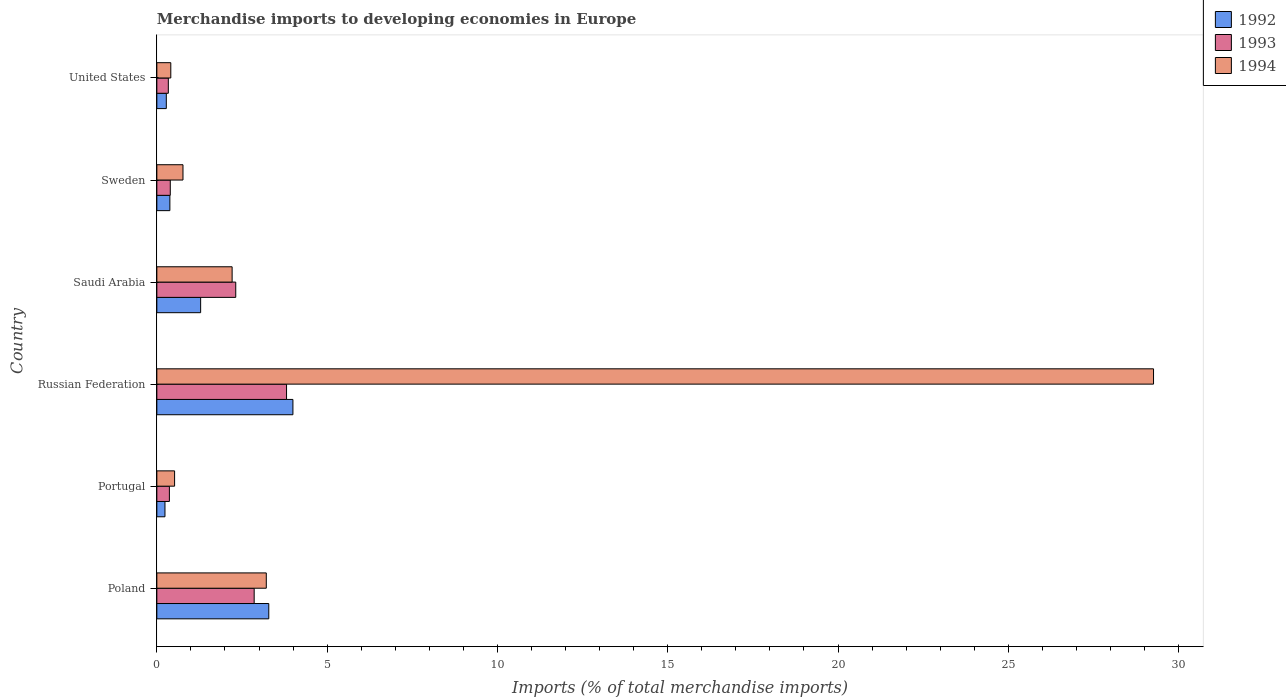Are the number of bars per tick equal to the number of legend labels?
Give a very brief answer. Yes. Are the number of bars on each tick of the Y-axis equal?
Offer a very short reply. Yes. What is the label of the 2nd group of bars from the top?
Offer a terse response. Sweden. In how many cases, is the number of bars for a given country not equal to the number of legend labels?
Provide a short and direct response. 0. What is the percentage total merchandise imports in 1992 in Saudi Arabia?
Offer a terse response. 1.29. Across all countries, what is the maximum percentage total merchandise imports in 1993?
Provide a short and direct response. 3.81. Across all countries, what is the minimum percentage total merchandise imports in 1993?
Make the answer very short. 0.34. In which country was the percentage total merchandise imports in 1994 maximum?
Offer a terse response. Russian Federation. What is the total percentage total merchandise imports in 1992 in the graph?
Keep it short and to the point. 9.47. What is the difference between the percentage total merchandise imports in 1993 in Russian Federation and that in Sweden?
Provide a succinct answer. 3.41. What is the difference between the percentage total merchandise imports in 1993 in Russian Federation and the percentage total merchandise imports in 1994 in Poland?
Your answer should be very brief. 0.59. What is the average percentage total merchandise imports in 1992 per country?
Your answer should be very brief. 1.58. What is the difference between the percentage total merchandise imports in 1994 and percentage total merchandise imports in 1993 in Saudi Arabia?
Provide a succinct answer. -0.11. What is the ratio of the percentage total merchandise imports in 1992 in Saudi Arabia to that in United States?
Ensure brevity in your answer.  4.63. What is the difference between the highest and the second highest percentage total merchandise imports in 1994?
Give a very brief answer. 26.05. What is the difference between the highest and the lowest percentage total merchandise imports in 1994?
Ensure brevity in your answer.  28.85. In how many countries, is the percentage total merchandise imports in 1994 greater than the average percentage total merchandise imports in 1994 taken over all countries?
Give a very brief answer. 1. Is the sum of the percentage total merchandise imports in 1992 in Poland and Sweden greater than the maximum percentage total merchandise imports in 1993 across all countries?
Make the answer very short. No. How many bars are there?
Offer a terse response. 18. Are all the bars in the graph horizontal?
Offer a very short reply. Yes. How many countries are there in the graph?
Your answer should be compact. 6. Are the values on the major ticks of X-axis written in scientific E-notation?
Offer a terse response. No. Does the graph contain any zero values?
Make the answer very short. No. How many legend labels are there?
Your response must be concise. 3. How are the legend labels stacked?
Your answer should be compact. Vertical. What is the title of the graph?
Your response must be concise. Merchandise imports to developing economies in Europe. What is the label or title of the X-axis?
Keep it short and to the point. Imports (% of total merchandise imports). What is the label or title of the Y-axis?
Provide a succinct answer. Country. What is the Imports (% of total merchandise imports) in 1992 in Poland?
Ensure brevity in your answer.  3.29. What is the Imports (% of total merchandise imports) in 1993 in Poland?
Provide a short and direct response. 2.86. What is the Imports (% of total merchandise imports) of 1994 in Poland?
Offer a terse response. 3.21. What is the Imports (% of total merchandise imports) of 1992 in Portugal?
Provide a short and direct response. 0.24. What is the Imports (% of total merchandise imports) in 1993 in Portugal?
Keep it short and to the point. 0.37. What is the Imports (% of total merchandise imports) of 1994 in Portugal?
Make the answer very short. 0.52. What is the Imports (% of total merchandise imports) in 1992 in Russian Federation?
Offer a very short reply. 4. What is the Imports (% of total merchandise imports) of 1993 in Russian Federation?
Your answer should be very brief. 3.81. What is the Imports (% of total merchandise imports) of 1994 in Russian Federation?
Offer a terse response. 29.26. What is the Imports (% of total merchandise imports) of 1992 in Saudi Arabia?
Ensure brevity in your answer.  1.29. What is the Imports (% of total merchandise imports) of 1993 in Saudi Arabia?
Provide a short and direct response. 2.32. What is the Imports (% of total merchandise imports) in 1994 in Saudi Arabia?
Keep it short and to the point. 2.21. What is the Imports (% of total merchandise imports) in 1992 in Sweden?
Make the answer very short. 0.38. What is the Imports (% of total merchandise imports) in 1993 in Sweden?
Provide a succinct answer. 0.39. What is the Imports (% of total merchandise imports) in 1994 in Sweden?
Make the answer very short. 0.77. What is the Imports (% of total merchandise imports) in 1992 in United States?
Make the answer very short. 0.28. What is the Imports (% of total merchandise imports) in 1993 in United States?
Offer a terse response. 0.34. What is the Imports (% of total merchandise imports) in 1994 in United States?
Provide a succinct answer. 0.41. Across all countries, what is the maximum Imports (% of total merchandise imports) in 1992?
Your answer should be very brief. 4. Across all countries, what is the maximum Imports (% of total merchandise imports) in 1993?
Your answer should be compact. 3.81. Across all countries, what is the maximum Imports (% of total merchandise imports) of 1994?
Give a very brief answer. 29.26. Across all countries, what is the minimum Imports (% of total merchandise imports) of 1992?
Provide a short and direct response. 0.24. Across all countries, what is the minimum Imports (% of total merchandise imports) of 1993?
Your answer should be very brief. 0.34. Across all countries, what is the minimum Imports (% of total merchandise imports) of 1994?
Provide a short and direct response. 0.41. What is the total Imports (% of total merchandise imports) of 1992 in the graph?
Provide a short and direct response. 9.47. What is the total Imports (% of total merchandise imports) of 1993 in the graph?
Your answer should be very brief. 10.08. What is the total Imports (% of total merchandise imports) of 1994 in the graph?
Offer a very short reply. 36.39. What is the difference between the Imports (% of total merchandise imports) in 1992 in Poland and that in Portugal?
Your answer should be very brief. 3.05. What is the difference between the Imports (% of total merchandise imports) of 1993 in Poland and that in Portugal?
Your answer should be compact. 2.49. What is the difference between the Imports (% of total merchandise imports) of 1994 in Poland and that in Portugal?
Your answer should be compact. 2.69. What is the difference between the Imports (% of total merchandise imports) of 1992 in Poland and that in Russian Federation?
Provide a short and direct response. -0.71. What is the difference between the Imports (% of total merchandise imports) in 1993 in Poland and that in Russian Federation?
Keep it short and to the point. -0.95. What is the difference between the Imports (% of total merchandise imports) in 1994 in Poland and that in Russian Federation?
Ensure brevity in your answer.  -26.05. What is the difference between the Imports (% of total merchandise imports) in 1992 in Poland and that in Saudi Arabia?
Your response must be concise. 2. What is the difference between the Imports (% of total merchandise imports) of 1993 in Poland and that in Saudi Arabia?
Make the answer very short. 0.54. What is the difference between the Imports (% of total merchandise imports) of 1992 in Poland and that in Sweden?
Your response must be concise. 2.9. What is the difference between the Imports (% of total merchandise imports) of 1993 in Poland and that in Sweden?
Provide a short and direct response. 2.46. What is the difference between the Imports (% of total merchandise imports) of 1994 in Poland and that in Sweden?
Your answer should be compact. 2.45. What is the difference between the Imports (% of total merchandise imports) of 1992 in Poland and that in United States?
Give a very brief answer. 3.01. What is the difference between the Imports (% of total merchandise imports) of 1993 in Poland and that in United States?
Give a very brief answer. 2.52. What is the difference between the Imports (% of total merchandise imports) in 1994 in Poland and that in United States?
Provide a succinct answer. 2.8. What is the difference between the Imports (% of total merchandise imports) of 1992 in Portugal and that in Russian Federation?
Offer a terse response. -3.76. What is the difference between the Imports (% of total merchandise imports) of 1993 in Portugal and that in Russian Federation?
Give a very brief answer. -3.44. What is the difference between the Imports (% of total merchandise imports) in 1994 in Portugal and that in Russian Federation?
Provide a short and direct response. -28.74. What is the difference between the Imports (% of total merchandise imports) of 1992 in Portugal and that in Saudi Arabia?
Your answer should be very brief. -1.05. What is the difference between the Imports (% of total merchandise imports) of 1993 in Portugal and that in Saudi Arabia?
Offer a terse response. -1.95. What is the difference between the Imports (% of total merchandise imports) of 1994 in Portugal and that in Saudi Arabia?
Your response must be concise. -1.69. What is the difference between the Imports (% of total merchandise imports) in 1992 in Portugal and that in Sweden?
Your response must be concise. -0.14. What is the difference between the Imports (% of total merchandise imports) in 1993 in Portugal and that in Sweden?
Make the answer very short. -0.03. What is the difference between the Imports (% of total merchandise imports) in 1994 in Portugal and that in Sweden?
Keep it short and to the point. -0.25. What is the difference between the Imports (% of total merchandise imports) in 1992 in Portugal and that in United States?
Ensure brevity in your answer.  -0.04. What is the difference between the Imports (% of total merchandise imports) of 1993 in Portugal and that in United States?
Offer a very short reply. 0.03. What is the difference between the Imports (% of total merchandise imports) of 1994 in Portugal and that in United States?
Provide a succinct answer. 0.11. What is the difference between the Imports (% of total merchandise imports) of 1992 in Russian Federation and that in Saudi Arabia?
Offer a very short reply. 2.71. What is the difference between the Imports (% of total merchandise imports) in 1993 in Russian Federation and that in Saudi Arabia?
Give a very brief answer. 1.49. What is the difference between the Imports (% of total merchandise imports) in 1994 in Russian Federation and that in Saudi Arabia?
Provide a short and direct response. 27.05. What is the difference between the Imports (% of total merchandise imports) of 1992 in Russian Federation and that in Sweden?
Ensure brevity in your answer.  3.61. What is the difference between the Imports (% of total merchandise imports) in 1993 in Russian Federation and that in Sweden?
Offer a terse response. 3.41. What is the difference between the Imports (% of total merchandise imports) in 1994 in Russian Federation and that in Sweden?
Your answer should be very brief. 28.5. What is the difference between the Imports (% of total merchandise imports) in 1992 in Russian Federation and that in United States?
Your answer should be compact. 3.72. What is the difference between the Imports (% of total merchandise imports) of 1993 in Russian Federation and that in United States?
Make the answer very short. 3.47. What is the difference between the Imports (% of total merchandise imports) in 1994 in Russian Federation and that in United States?
Give a very brief answer. 28.85. What is the difference between the Imports (% of total merchandise imports) in 1992 in Saudi Arabia and that in Sweden?
Your answer should be very brief. 0.9. What is the difference between the Imports (% of total merchandise imports) in 1993 in Saudi Arabia and that in Sweden?
Provide a short and direct response. 1.92. What is the difference between the Imports (% of total merchandise imports) in 1994 in Saudi Arabia and that in Sweden?
Give a very brief answer. 1.44. What is the difference between the Imports (% of total merchandise imports) of 1993 in Saudi Arabia and that in United States?
Make the answer very short. 1.98. What is the difference between the Imports (% of total merchandise imports) of 1994 in Saudi Arabia and that in United States?
Your response must be concise. 1.8. What is the difference between the Imports (% of total merchandise imports) in 1992 in Sweden and that in United States?
Ensure brevity in your answer.  0.1. What is the difference between the Imports (% of total merchandise imports) of 1993 in Sweden and that in United States?
Your response must be concise. 0.06. What is the difference between the Imports (% of total merchandise imports) of 1994 in Sweden and that in United States?
Your response must be concise. 0.36. What is the difference between the Imports (% of total merchandise imports) in 1992 in Poland and the Imports (% of total merchandise imports) in 1993 in Portugal?
Make the answer very short. 2.92. What is the difference between the Imports (% of total merchandise imports) of 1992 in Poland and the Imports (% of total merchandise imports) of 1994 in Portugal?
Provide a succinct answer. 2.77. What is the difference between the Imports (% of total merchandise imports) in 1993 in Poland and the Imports (% of total merchandise imports) in 1994 in Portugal?
Provide a short and direct response. 2.34. What is the difference between the Imports (% of total merchandise imports) of 1992 in Poland and the Imports (% of total merchandise imports) of 1993 in Russian Federation?
Your answer should be very brief. -0.52. What is the difference between the Imports (% of total merchandise imports) in 1992 in Poland and the Imports (% of total merchandise imports) in 1994 in Russian Federation?
Provide a succinct answer. -25.98. What is the difference between the Imports (% of total merchandise imports) of 1993 in Poland and the Imports (% of total merchandise imports) of 1994 in Russian Federation?
Offer a terse response. -26.41. What is the difference between the Imports (% of total merchandise imports) in 1992 in Poland and the Imports (% of total merchandise imports) in 1993 in Saudi Arabia?
Provide a succinct answer. 0.97. What is the difference between the Imports (% of total merchandise imports) of 1992 in Poland and the Imports (% of total merchandise imports) of 1994 in Saudi Arabia?
Ensure brevity in your answer.  1.08. What is the difference between the Imports (% of total merchandise imports) in 1993 in Poland and the Imports (% of total merchandise imports) in 1994 in Saudi Arabia?
Offer a very short reply. 0.65. What is the difference between the Imports (% of total merchandise imports) of 1992 in Poland and the Imports (% of total merchandise imports) of 1993 in Sweden?
Provide a short and direct response. 2.89. What is the difference between the Imports (% of total merchandise imports) in 1992 in Poland and the Imports (% of total merchandise imports) in 1994 in Sweden?
Provide a succinct answer. 2.52. What is the difference between the Imports (% of total merchandise imports) of 1993 in Poland and the Imports (% of total merchandise imports) of 1994 in Sweden?
Keep it short and to the point. 2.09. What is the difference between the Imports (% of total merchandise imports) of 1992 in Poland and the Imports (% of total merchandise imports) of 1993 in United States?
Provide a succinct answer. 2.95. What is the difference between the Imports (% of total merchandise imports) of 1992 in Poland and the Imports (% of total merchandise imports) of 1994 in United States?
Your response must be concise. 2.88. What is the difference between the Imports (% of total merchandise imports) in 1993 in Poland and the Imports (% of total merchandise imports) in 1994 in United States?
Your response must be concise. 2.45. What is the difference between the Imports (% of total merchandise imports) of 1992 in Portugal and the Imports (% of total merchandise imports) of 1993 in Russian Federation?
Offer a terse response. -3.57. What is the difference between the Imports (% of total merchandise imports) of 1992 in Portugal and the Imports (% of total merchandise imports) of 1994 in Russian Federation?
Provide a succinct answer. -29.03. What is the difference between the Imports (% of total merchandise imports) of 1993 in Portugal and the Imports (% of total merchandise imports) of 1994 in Russian Federation?
Offer a terse response. -28.9. What is the difference between the Imports (% of total merchandise imports) in 1992 in Portugal and the Imports (% of total merchandise imports) in 1993 in Saudi Arabia?
Give a very brief answer. -2.08. What is the difference between the Imports (% of total merchandise imports) in 1992 in Portugal and the Imports (% of total merchandise imports) in 1994 in Saudi Arabia?
Give a very brief answer. -1.97. What is the difference between the Imports (% of total merchandise imports) of 1993 in Portugal and the Imports (% of total merchandise imports) of 1994 in Saudi Arabia?
Offer a terse response. -1.84. What is the difference between the Imports (% of total merchandise imports) of 1992 in Portugal and the Imports (% of total merchandise imports) of 1993 in Sweden?
Your answer should be compact. -0.16. What is the difference between the Imports (% of total merchandise imports) of 1992 in Portugal and the Imports (% of total merchandise imports) of 1994 in Sweden?
Your answer should be compact. -0.53. What is the difference between the Imports (% of total merchandise imports) of 1993 in Portugal and the Imports (% of total merchandise imports) of 1994 in Sweden?
Offer a very short reply. -0.4. What is the difference between the Imports (% of total merchandise imports) in 1992 in Portugal and the Imports (% of total merchandise imports) in 1993 in United States?
Your answer should be compact. -0.1. What is the difference between the Imports (% of total merchandise imports) of 1992 in Portugal and the Imports (% of total merchandise imports) of 1994 in United States?
Make the answer very short. -0.17. What is the difference between the Imports (% of total merchandise imports) in 1993 in Portugal and the Imports (% of total merchandise imports) in 1994 in United States?
Offer a very short reply. -0.04. What is the difference between the Imports (% of total merchandise imports) in 1992 in Russian Federation and the Imports (% of total merchandise imports) in 1993 in Saudi Arabia?
Make the answer very short. 1.68. What is the difference between the Imports (% of total merchandise imports) in 1992 in Russian Federation and the Imports (% of total merchandise imports) in 1994 in Saudi Arabia?
Give a very brief answer. 1.79. What is the difference between the Imports (% of total merchandise imports) in 1993 in Russian Federation and the Imports (% of total merchandise imports) in 1994 in Saudi Arabia?
Offer a very short reply. 1.6. What is the difference between the Imports (% of total merchandise imports) of 1992 in Russian Federation and the Imports (% of total merchandise imports) of 1993 in Sweden?
Your answer should be very brief. 3.6. What is the difference between the Imports (% of total merchandise imports) of 1992 in Russian Federation and the Imports (% of total merchandise imports) of 1994 in Sweden?
Your answer should be compact. 3.23. What is the difference between the Imports (% of total merchandise imports) in 1993 in Russian Federation and the Imports (% of total merchandise imports) in 1994 in Sweden?
Your response must be concise. 3.04. What is the difference between the Imports (% of total merchandise imports) in 1992 in Russian Federation and the Imports (% of total merchandise imports) in 1993 in United States?
Ensure brevity in your answer.  3.66. What is the difference between the Imports (% of total merchandise imports) of 1992 in Russian Federation and the Imports (% of total merchandise imports) of 1994 in United States?
Your response must be concise. 3.59. What is the difference between the Imports (% of total merchandise imports) of 1993 in Russian Federation and the Imports (% of total merchandise imports) of 1994 in United States?
Your response must be concise. 3.4. What is the difference between the Imports (% of total merchandise imports) of 1992 in Saudi Arabia and the Imports (% of total merchandise imports) of 1993 in Sweden?
Your answer should be very brief. 0.89. What is the difference between the Imports (% of total merchandise imports) of 1992 in Saudi Arabia and the Imports (% of total merchandise imports) of 1994 in Sweden?
Make the answer very short. 0.52. What is the difference between the Imports (% of total merchandise imports) of 1993 in Saudi Arabia and the Imports (% of total merchandise imports) of 1994 in Sweden?
Give a very brief answer. 1.55. What is the difference between the Imports (% of total merchandise imports) in 1992 in Saudi Arabia and the Imports (% of total merchandise imports) in 1993 in United States?
Offer a very short reply. 0.95. What is the difference between the Imports (% of total merchandise imports) of 1992 in Saudi Arabia and the Imports (% of total merchandise imports) of 1994 in United States?
Provide a short and direct response. 0.88. What is the difference between the Imports (% of total merchandise imports) of 1993 in Saudi Arabia and the Imports (% of total merchandise imports) of 1994 in United States?
Provide a succinct answer. 1.91. What is the difference between the Imports (% of total merchandise imports) of 1992 in Sweden and the Imports (% of total merchandise imports) of 1993 in United States?
Offer a terse response. 0.05. What is the difference between the Imports (% of total merchandise imports) of 1992 in Sweden and the Imports (% of total merchandise imports) of 1994 in United States?
Make the answer very short. -0.03. What is the difference between the Imports (% of total merchandise imports) of 1993 in Sweden and the Imports (% of total merchandise imports) of 1994 in United States?
Ensure brevity in your answer.  -0.02. What is the average Imports (% of total merchandise imports) of 1992 per country?
Your answer should be very brief. 1.58. What is the average Imports (% of total merchandise imports) of 1993 per country?
Give a very brief answer. 1.68. What is the average Imports (% of total merchandise imports) of 1994 per country?
Offer a very short reply. 6.06. What is the difference between the Imports (% of total merchandise imports) in 1992 and Imports (% of total merchandise imports) in 1993 in Poland?
Your answer should be very brief. 0.43. What is the difference between the Imports (% of total merchandise imports) in 1992 and Imports (% of total merchandise imports) in 1994 in Poland?
Make the answer very short. 0.07. What is the difference between the Imports (% of total merchandise imports) of 1993 and Imports (% of total merchandise imports) of 1994 in Poland?
Offer a very short reply. -0.36. What is the difference between the Imports (% of total merchandise imports) in 1992 and Imports (% of total merchandise imports) in 1993 in Portugal?
Offer a very short reply. -0.13. What is the difference between the Imports (% of total merchandise imports) of 1992 and Imports (% of total merchandise imports) of 1994 in Portugal?
Your answer should be very brief. -0.28. What is the difference between the Imports (% of total merchandise imports) of 1993 and Imports (% of total merchandise imports) of 1994 in Portugal?
Keep it short and to the point. -0.15. What is the difference between the Imports (% of total merchandise imports) of 1992 and Imports (% of total merchandise imports) of 1993 in Russian Federation?
Offer a very short reply. 0.19. What is the difference between the Imports (% of total merchandise imports) in 1992 and Imports (% of total merchandise imports) in 1994 in Russian Federation?
Your response must be concise. -25.27. What is the difference between the Imports (% of total merchandise imports) in 1993 and Imports (% of total merchandise imports) in 1994 in Russian Federation?
Ensure brevity in your answer.  -25.46. What is the difference between the Imports (% of total merchandise imports) of 1992 and Imports (% of total merchandise imports) of 1993 in Saudi Arabia?
Your answer should be very brief. -1.03. What is the difference between the Imports (% of total merchandise imports) in 1992 and Imports (% of total merchandise imports) in 1994 in Saudi Arabia?
Offer a terse response. -0.92. What is the difference between the Imports (% of total merchandise imports) of 1993 and Imports (% of total merchandise imports) of 1994 in Saudi Arabia?
Your response must be concise. 0.11. What is the difference between the Imports (% of total merchandise imports) of 1992 and Imports (% of total merchandise imports) of 1993 in Sweden?
Ensure brevity in your answer.  -0.01. What is the difference between the Imports (% of total merchandise imports) of 1992 and Imports (% of total merchandise imports) of 1994 in Sweden?
Keep it short and to the point. -0.39. What is the difference between the Imports (% of total merchandise imports) in 1993 and Imports (% of total merchandise imports) in 1994 in Sweden?
Your response must be concise. -0.37. What is the difference between the Imports (% of total merchandise imports) in 1992 and Imports (% of total merchandise imports) in 1993 in United States?
Offer a terse response. -0.06. What is the difference between the Imports (% of total merchandise imports) of 1992 and Imports (% of total merchandise imports) of 1994 in United States?
Your response must be concise. -0.13. What is the difference between the Imports (% of total merchandise imports) in 1993 and Imports (% of total merchandise imports) in 1994 in United States?
Make the answer very short. -0.07. What is the ratio of the Imports (% of total merchandise imports) in 1992 in Poland to that in Portugal?
Your answer should be very brief. 13.77. What is the ratio of the Imports (% of total merchandise imports) of 1993 in Poland to that in Portugal?
Your answer should be compact. 7.76. What is the ratio of the Imports (% of total merchandise imports) in 1994 in Poland to that in Portugal?
Keep it short and to the point. 6.17. What is the ratio of the Imports (% of total merchandise imports) in 1992 in Poland to that in Russian Federation?
Your answer should be very brief. 0.82. What is the ratio of the Imports (% of total merchandise imports) of 1993 in Poland to that in Russian Federation?
Offer a very short reply. 0.75. What is the ratio of the Imports (% of total merchandise imports) in 1994 in Poland to that in Russian Federation?
Provide a short and direct response. 0.11. What is the ratio of the Imports (% of total merchandise imports) in 1992 in Poland to that in Saudi Arabia?
Provide a short and direct response. 2.56. What is the ratio of the Imports (% of total merchandise imports) in 1993 in Poland to that in Saudi Arabia?
Give a very brief answer. 1.23. What is the ratio of the Imports (% of total merchandise imports) of 1994 in Poland to that in Saudi Arabia?
Your answer should be compact. 1.45. What is the ratio of the Imports (% of total merchandise imports) in 1992 in Poland to that in Sweden?
Offer a very short reply. 8.59. What is the ratio of the Imports (% of total merchandise imports) of 1993 in Poland to that in Sweden?
Your response must be concise. 7.25. What is the ratio of the Imports (% of total merchandise imports) of 1994 in Poland to that in Sweden?
Your answer should be compact. 4.19. What is the ratio of the Imports (% of total merchandise imports) in 1992 in Poland to that in United States?
Your response must be concise. 11.83. What is the ratio of the Imports (% of total merchandise imports) in 1993 in Poland to that in United States?
Provide a succinct answer. 8.48. What is the ratio of the Imports (% of total merchandise imports) in 1994 in Poland to that in United States?
Ensure brevity in your answer.  7.84. What is the ratio of the Imports (% of total merchandise imports) in 1992 in Portugal to that in Russian Federation?
Your response must be concise. 0.06. What is the ratio of the Imports (% of total merchandise imports) in 1993 in Portugal to that in Russian Federation?
Your answer should be very brief. 0.1. What is the ratio of the Imports (% of total merchandise imports) of 1994 in Portugal to that in Russian Federation?
Offer a terse response. 0.02. What is the ratio of the Imports (% of total merchandise imports) of 1992 in Portugal to that in Saudi Arabia?
Your response must be concise. 0.19. What is the ratio of the Imports (% of total merchandise imports) in 1993 in Portugal to that in Saudi Arabia?
Make the answer very short. 0.16. What is the ratio of the Imports (% of total merchandise imports) of 1994 in Portugal to that in Saudi Arabia?
Offer a very short reply. 0.24. What is the ratio of the Imports (% of total merchandise imports) of 1992 in Portugal to that in Sweden?
Give a very brief answer. 0.62. What is the ratio of the Imports (% of total merchandise imports) in 1993 in Portugal to that in Sweden?
Your answer should be very brief. 0.93. What is the ratio of the Imports (% of total merchandise imports) of 1994 in Portugal to that in Sweden?
Offer a terse response. 0.68. What is the ratio of the Imports (% of total merchandise imports) in 1992 in Portugal to that in United States?
Your response must be concise. 0.86. What is the ratio of the Imports (% of total merchandise imports) of 1993 in Portugal to that in United States?
Keep it short and to the point. 1.09. What is the ratio of the Imports (% of total merchandise imports) in 1994 in Portugal to that in United States?
Ensure brevity in your answer.  1.27. What is the ratio of the Imports (% of total merchandise imports) of 1992 in Russian Federation to that in Saudi Arabia?
Offer a very short reply. 3.11. What is the ratio of the Imports (% of total merchandise imports) in 1993 in Russian Federation to that in Saudi Arabia?
Keep it short and to the point. 1.64. What is the ratio of the Imports (% of total merchandise imports) in 1994 in Russian Federation to that in Saudi Arabia?
Give a very brief answer. 13.24. What is the ratio of the Imports (% of total merchandise imports) of 1992 in Russian Federation to that in Sweden?
Ensure brevity in your answer.  10.44. What is the ratio of the Imports (% of total merchandise imports) in 1993 in Russian Federation to that in Sweden?
Your response must be concise. 9.66. What is the ratio of the Imports (% of total merchandise imports) in 1994 in Russian Federation to that in Sweden?
Keep it short and to the point. 38.12. What is the ratio of the Imports (% of total merchandise imports) of 1992 in Russian Federation to that in United States?
Make the answer very short. 14.38. What is the ratio of the Imports (% of total merchandise imports) of 1993 in Russian Federation to that in United States?
Provide a short and direct response. 11.3. What is the ratio of the Imports (% of total merchandise imports) in 1994 in Russian Federation to that in United States?
Offer a terse response. 71.41. What is the ratio of the Imports (% of total merchandise imports) in 1992 in Saudi Arabia to that in Sweden?
Your response must be concise. 3.36. What is the ratio of the Imports (% of total merchandise imports) in 1993 in Saudi Arabia to that in Sweden?
Ensure brevity in your answer.  5.87. What is the ratio of the Imports (% of total merchandise imports) of 1994 in Saudi Arabia to that in Sweden?
Provide a short and direct response. 2.88. What is the ratio of the Imports (% of total merchandise imports) in 1992 in Saudi Arabia to that in United States?
Keep it short and to the point. 4.63. What is the ratio of the Imports (% of total merchandise imports) of 1993 in Saudi Arabia to that in United States?
Make the answer very short. 6.87. What is the ratio of the Imports (% of total merchandise imports) in 1994 in Saudi Arabia to that in United States?
Keep it short and to the point. 5.39. What is the ratio of the Imports (% of total merchandise imports) of 1992 in Sweden to that in United States?
Your response must be concise. 1.38. What is the ratio of the Imports (% of total merchandise imports) of 1993 in Sweden to that in United States?
Give a very brief answer. 1.17. What is the ratio of the Imports (% of total merchandise imports) of 1994 in Sweden to that in United States?
Give a very brief answer. 1.87. What is the difference between the highest and the second highest Imports (% of total merchandise imports) of 1992?
Provide a short and direct response. 0.71. What is the difference between the highest and the second highest Imports (% of total merchandise imports) in 1993?
Give a very brief answer. 0.95. What is the difference between the highest and the second highest Imports (% of total merchandise imports) of 1994?
Offer a terse response. 26.05. What is the difference between the highest and the lowest Imports (% of total merchandise imports) in 1992?
Make the answer very short. 3.76. What is the difference between the highest and the lowest Imports (% of total merchandise imports) in 1993?
Make the answer very short. 3.47. What is the difference between the highest and the lowest Imports (% of total merchandise imports) of 1994?
Keep it short and to the point. 28.85. 